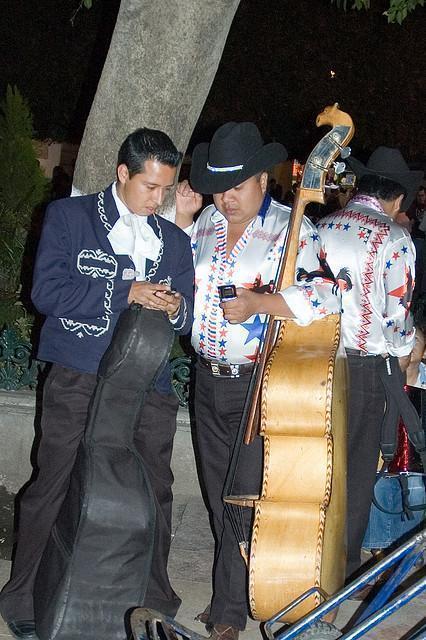What kind of music band do they play music in?
Make your selection and explain in format: 'Answer: answer
Rationale: rationale.'
Options: Pop, rock, mariachi, country. Answer: mariachi.
Rationale: They have the style of clothes and look like they are hispanic. 